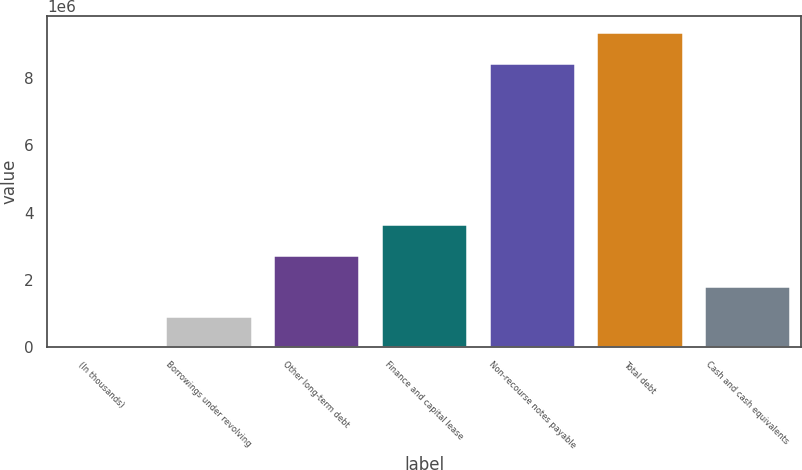<chart> <loc_0><loc_0><loc_500><loc_500><bar_chart><fcel>(In thousands)<fcel>Borrowings under revolving<fcel>Other long-term debt<fcel>Finance and capital lease<fcel>Non-recourse notes payable<fcel>Total debt<fcel>Cash and cash equivalents<nl><fcel>2015<fcel>912739<fcel>2.73419e+06<fcel>3.64491e+06<fcel>8.47063e+06<fcel>9.38135e+06<fcel>1.82346e+06<nl></chart> 